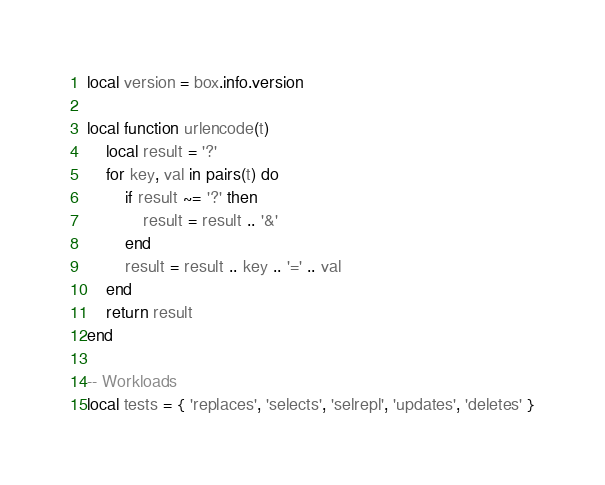<code> <loc_0><loc_0><loc_500><loc_500><_Lua_>local version = box.info.version

local function urlencode(t)
    local result = '?'
    for key, val in pairs(t) do
        if result ~= '?' then
            result = result .. '&'
        end
        result = result .. key .. '=' .. val
    end
    return result
end

-- Workloads
local tests = { 'replaces', 'selects', 'selrepl', 'updates', 'deletes' }</code> 